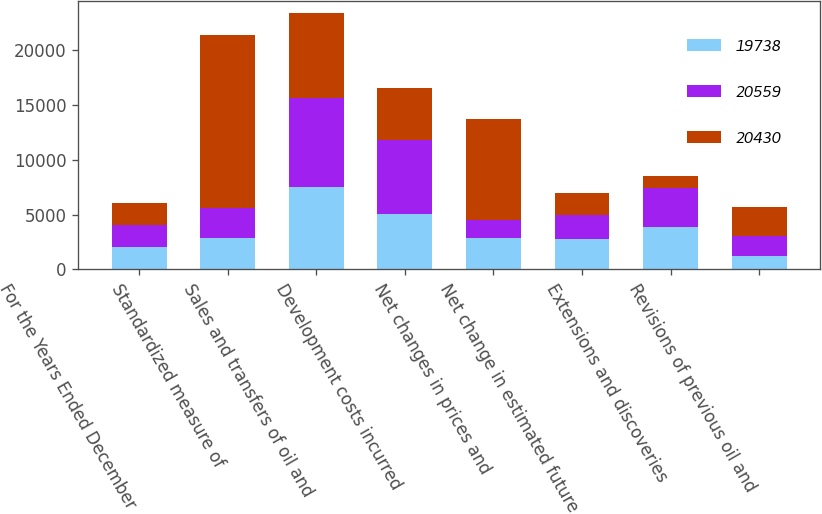Convert chart. <chart><loc_0><loc_0><loc_500><loc_500><stacked_bar_chart><ecel><fcel>For the Years Ended December<fcel>Standardized measure of<fcel>Sales and transfers of oil and<fcel>Development costs incurred<fcel>Net changes in prices and<fcel>Net change in estimated future<fcel>Extensions and discoveries<fcel>Revisions of previous oil and<nl><fcel>19738<fcel>2013<fcel>2822.5<fcel>7507<fcel>5051<fcel>2847<fcel>2798<fcel>3836<fcel>1189<nl><fcel>20559<fcel>2012<fcel>2822.5<fcel>8141<fcel>6790<fcel>1678<fcel>2181<fcel>3612<fcel>1890<nl><fcel>20430<fcel>2011<fcel>15702<fcel>7695<fcel>4673<fcel>9233<fcel>1963<fcel>1040<fcel>2587<nl></chart> 